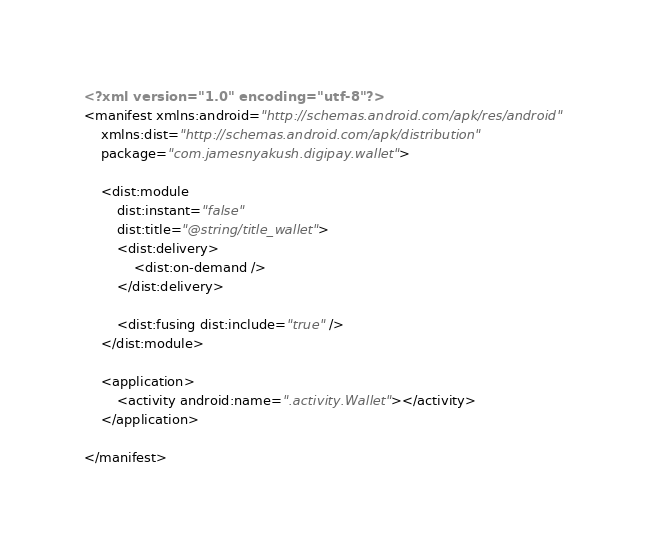Convert code to text. <code><loc_0><loc_0><loc_500><loc_500><_XML_><?xml version="1.0" encoding="utf-8"?>
<manifest xmlns:android="http://schemas.android.com/apk/res/android"
    xmlns:dist="http://schemas.android.com/apk/distribution"
    package="com.jamesnyakush.digipay.wallet">

    <dist:module
        dist:instant="false"
        dist:title="@string/title_wallet">
        <dist:delivery>
            <dist:on-demand />
        </dist:delivery>

        <dist:fusing dist:include="true" />
    </dist:module>

    <application>
        <activity android:name=".activity.Wallet"></activity>
    </application>

</manifest></code> 